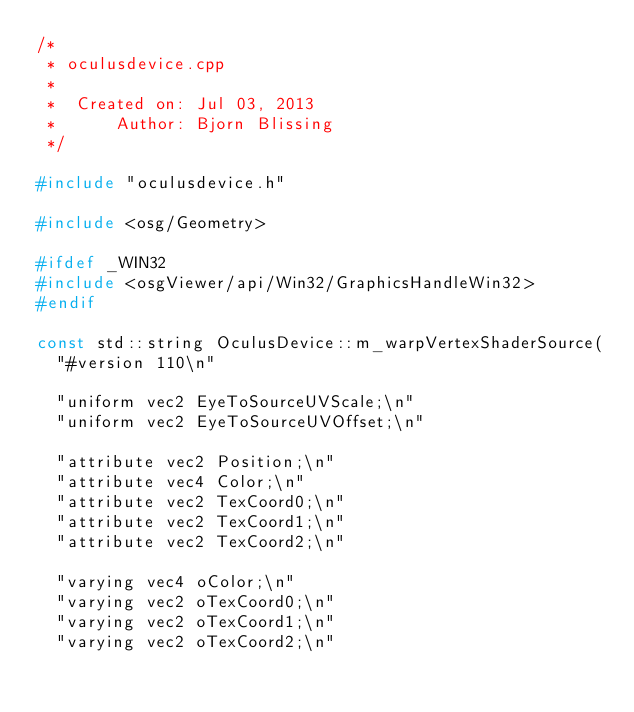<code> <loc_0><loc_0><loc_500><loc_500><_C++_>/*
 * oculusdevice.cpp
 *
 *  Created on: Jul 03, 2013
 *      Author: Bjorn Blissing
 */

#include "oculusdevice.h"

#include <osg/Geometry>

#ifdef _WIN32
#include <osgViewer/api/Win32/GraphicsHandleWin32>
#endif

const std::string OculusDevice::m_warpVertexShaderSource(
	"#version 110\n"

	"uniform vec2 EyeToSourceUVScale;\n"
	"uniform vec2 EyeToSourceUVOffset;\n"

	"attribute vec2 Position;\n"
	"attribute vec4 Color;\n"
	"attribute vec2 TexCoord0;\n"
	"attribute vec2 TexCoord1;\n"
	"attribute vec2 TexCoord2;\n"

	"varying vec4 oColor;\n"
	"varying vec2 oTexCoord0;\n"
	"varying vec2 oTexCoord1;\n"
	"varying vec2 oTexCoord2;\n"
</code> 